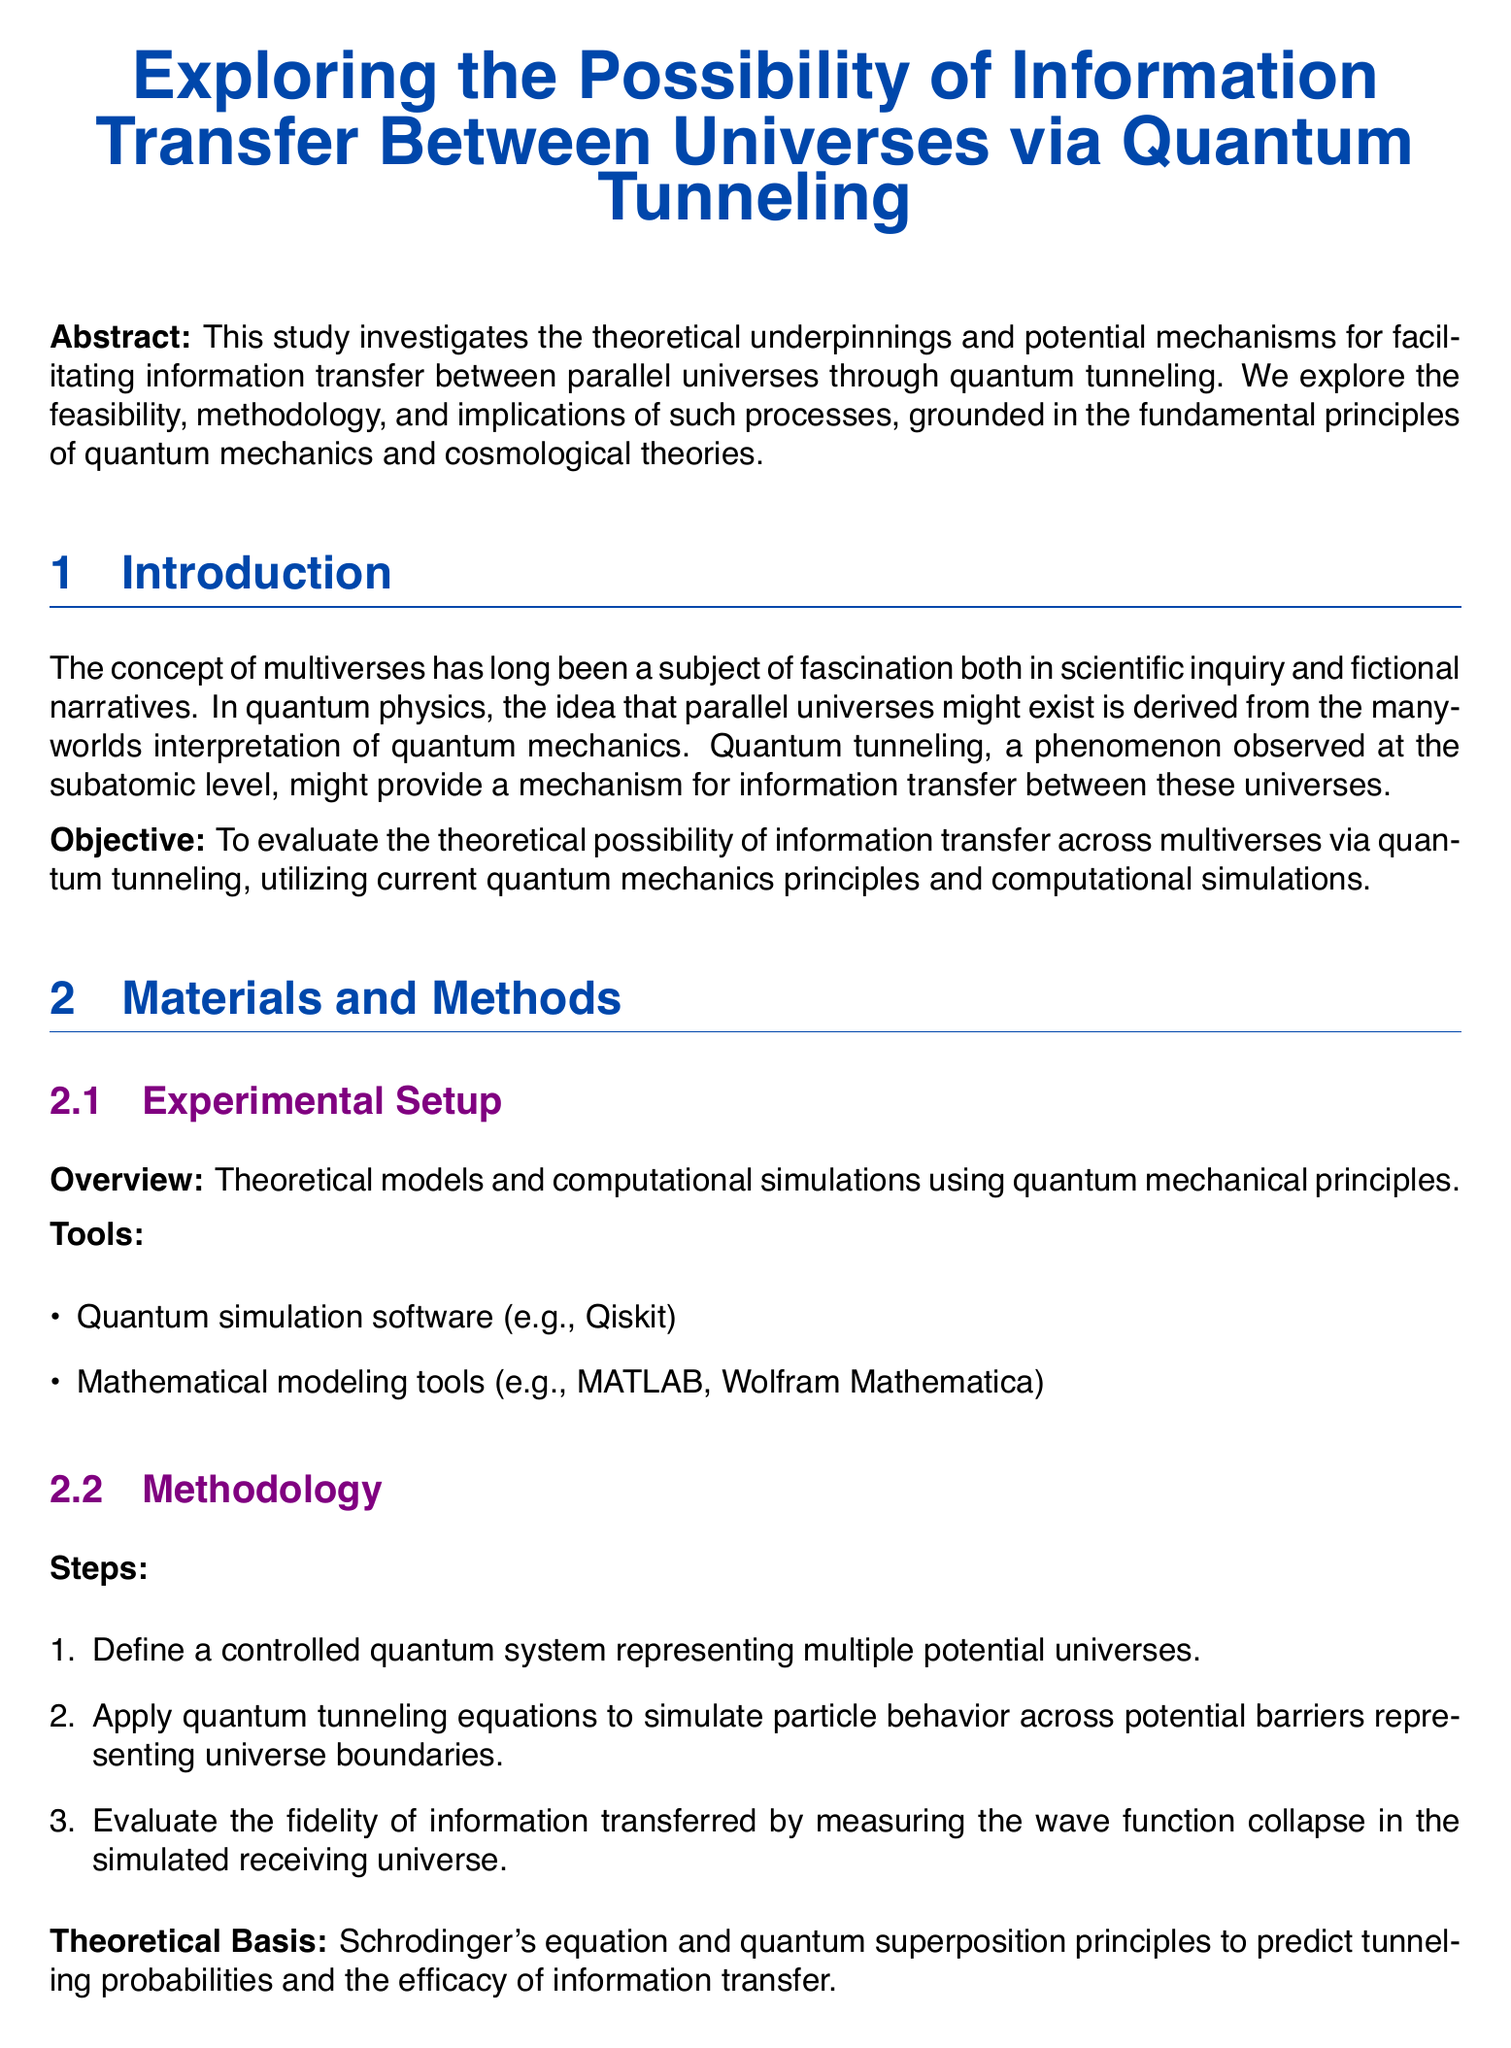What is the title of the study? The title is stated at the beginning of the document and reflects the main focus of the research.
Answer: Exploring the Possibility of Information Transfer Between Universes via Quantum Tunneling What principle is primarily used to evaluate tunneling probabilities? The principle mentioned in the methodology section serves as a foundational theoretical basis for the simulations.
Answer: Schrodinger's equation What was the measurement accuracy for Universe Model A? This is found in the results section, indicating the level of precision achieved in that particular model.
Answer: 80% Which simulation software was used in this study? The tools section lists specific software used for quantum simulations, reflecting the resources utilized.
Answer: Qiskit What is the main statistical tool employed for data analysis in the study? The analysis section mentions the method used to compare transfer success, indicating the analytical approach taken.
Answer: ANOVA What was the percentage of successful transfer events in Universe Model B? This percentage is reported in the results section, indicating the effectiveness of the transfer in that model.
Answer: 70% What challenges are mentioned regarding real-world application? The limitations section discusses specific constraints impacting the feasibility of implementing these theories practically.
Answer: Computational constraints What future work is proposed in the document? The future work section outlines the next steps suggested by the authors based on their current findings.
Answer: Refined simulations What is the objective stated in the report? The objective section provides a clear goal for the research, summarizing the focus of the investigation.
Answer: Evaluate the theoretical possibility of information transfer across multiverses via quantum tunneling 